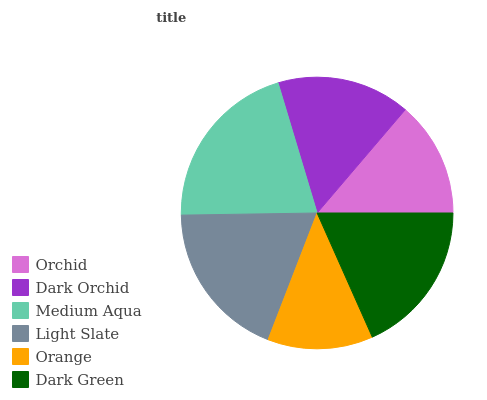Is Orange the minimum?
Answer yes or no. Yes. Is Medium Aqua the maximum?
Answer yes or no. Yes. Is Dark Orchid the minimum?
Answer yes or no. No. Is Dark Orchid the maximum?
Answer yes or no. No. Is Dark Orchid greater than Orchid?
Answer yes or no. Yes. Is Orchid less than Dark Orchid?
Answer yes or no. Yes. Is Orchid greater than Dark Orchid?
Answer yes or no. No. Is Dark Orchid less than Orchid?
Answer yes or no. No. Is Dark Green the high median?
Answer yes or no. Yes. Is Dark Orchid the low median?
Answer yes or no. Yes. Is Orange the high median?
Answer yes or no. No. Is Dark Green the low median?
Answer yes or no. No. 